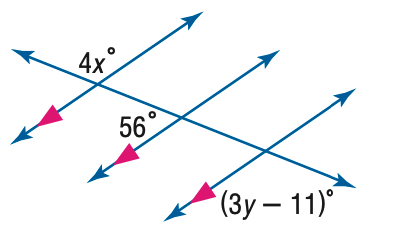Answer the mathemtical geometry problem and directly provide the correct option letter.
Question: Find x in the figure.
Choices: A: 14 B: 31 C: 45 D: 56 B 